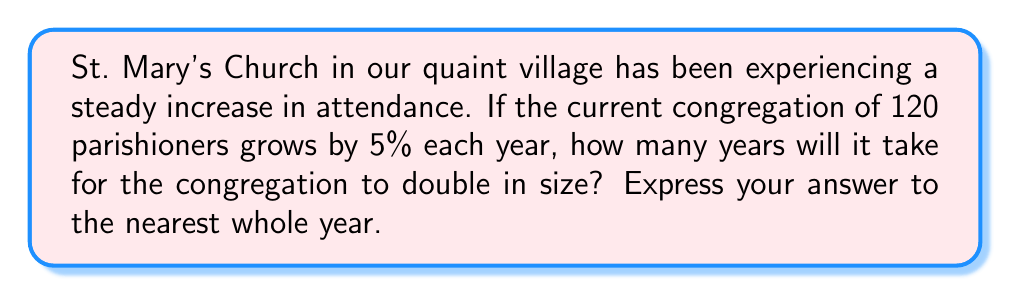Solve this math problem. Let's approach this step-by-step using an exponential growth function:

1) The exponential growth function is given by:
   $A(t) = A_0(1+r)^t$
   Where $A_0$ is the initial amount, $r$ is the growth rate, and $t$ is time.

2) We want to find $t$ when $A(t) = 2A_0$:
   $2A_0 = A_0(1+0.05)^t$

3) Dividing both sides by $A_0$:
   $2 = (1.05)^t$

4) Taking the natural logarithm of both sides:
   $\ln(2) = t \ln(1.05)$

5) Solving for $t$:
   $t = \frac{\ln(2)}{\ln(1.05)}$

6) Using a calculator:
   $t \approx 14.2067$

7) Rounding to the nearest whole year:
   $t \approx 14$ years
Answer: 14 years 